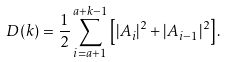<formula> <loc_0><loc_0><loc_500><loc_500>D ( k ) = \frac { 1 } { 2 } \sum _ { i = a + 1 } ^ { a + k - 1 } \left [ | A _ { i } | ^ { 2 } + | A _ { i - 1 } | ^ { 2 } \right ] .</formula> 